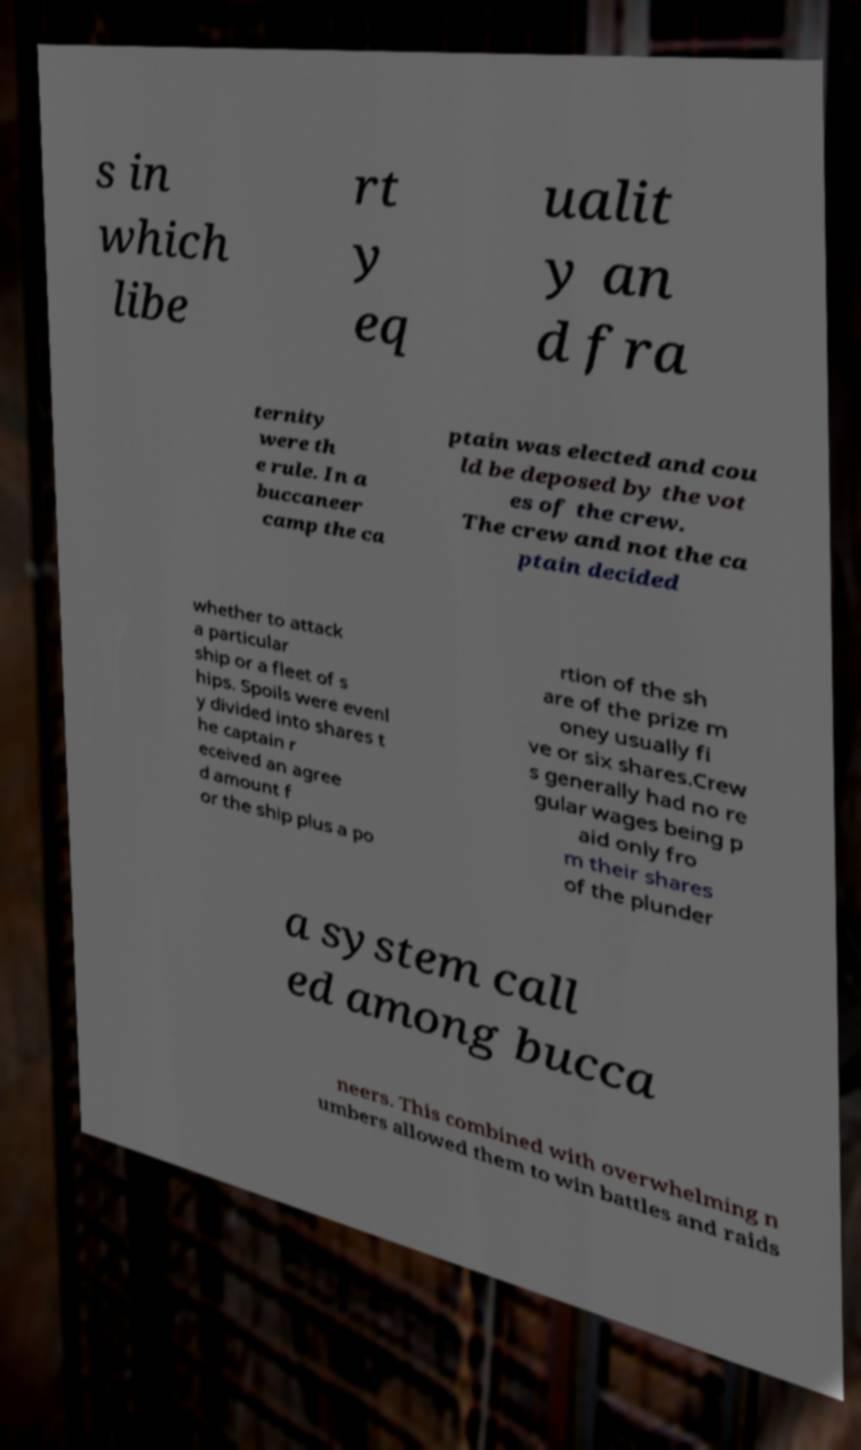Can you read and provide the text displayed in the image?This photo seems to have some interesting text. Can you extract and type it out for me? s in which libe rt y eq ualit y an d fra ternity were th e rule. In a buccaneer camp the ca ptain was elected and cou ld be deposed by the vot es of the crew. The crew and not the ca ptain decided whether to attack a particular ship or a fleet of s hips. Spoils were evenl y divided into shares t he captain r eceived an agree d amount f or the ship plus a po rtion of the sh are of the prize m oney usually fi ve or six shares.Crew s generally had no re gular wages being p aid only fro m their shares of the plunder a system call ed among bucca neers. This combined with overwhelming n umbers allowed them to win battles and raids 